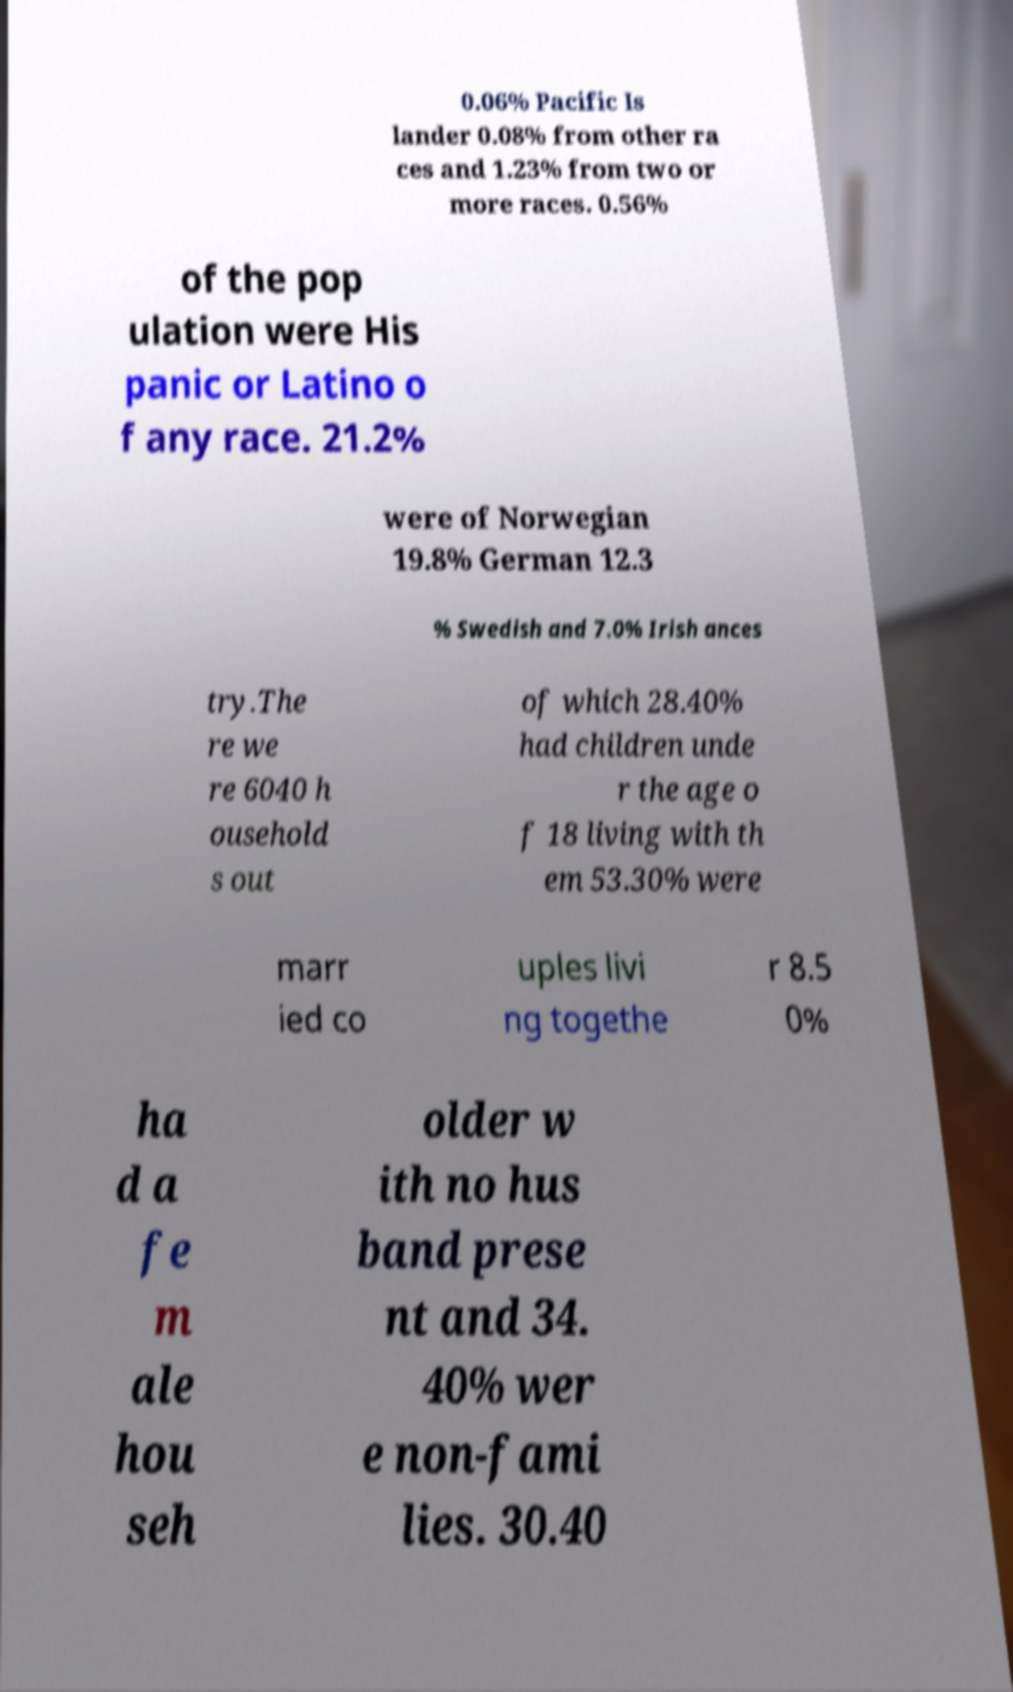For documentation purposes, I need the text within this image transcribed. Could you provide that? 0.06% Pacific Is lander 0.08% from other ra ces and 1.23% from two or more races. 0.56% of the pop ulation were His panic or Latino o f any race. 21.2% were of Norwegian 19.8% German 12.3 % Swedish and 7.0% Irish ances try.The re we re 6040 h ousehold s out of which 28.40% had children unde r the age o f 18 living with th em 53.30% were marr ied co uples livi ng togethe r 8.5 0% ha d a fe m ale hou seh older w ith no hus band prese nt and 34. 40% wer e non-fami lies. 30.40 